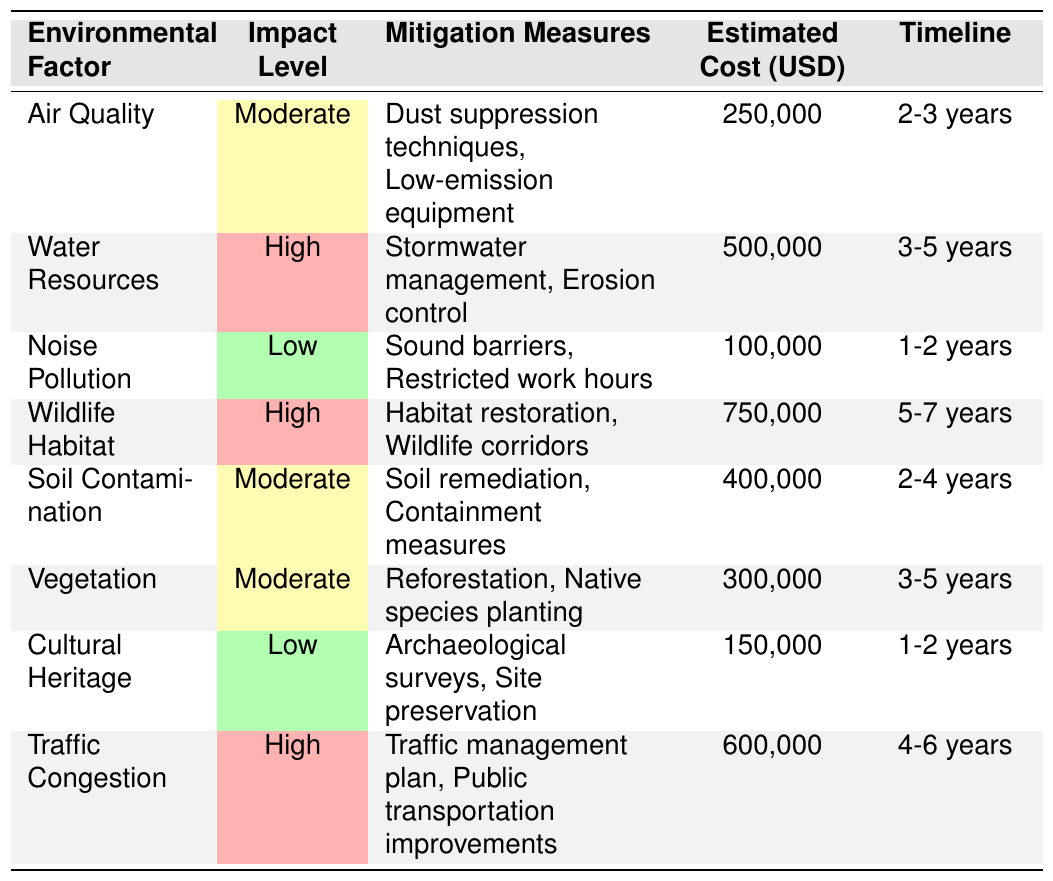What is the estimated cost for managing wildlife habitat? The table shows that the estimated cost for wildlife habitat management is listed as 750,000 USD.
Answer: 750,000 USD What mitigation measure is recommended for high water resource impact? For high water resource impact, the recommended mitigation measures are stormwater management and erosion control.
Answer: Stormwater management, erosion control Which environmental factor has the lowest impact level? Noise pollution and cultural heritage both have a low impact level indicated in the table.
Answer: Noise pollution and cultural heritage What is the total estimated cost for mitigating air quality and soil contamination? The estimated costs for air quality (250,000 USD) and soil contamination (400,000 USD) are summed: 250,000 + 400,000 = 650,000 USD.
Answer: 650,000 USD Are any environmental factors classified as having a moderate impact level? Yes, air quality, soil contamination, and vegetation are listed with a moderate impact level.
Answer: Yes How many years will it take to mitigate the water resources? The timeline for mitigating water resources is estimated at 3 to 5 years according to the table.
Answer: 3-5 years Which environmental factor requires the highest estimated cost for mitigation? The highest estimated cost for mitigation is for wildlife habitat, listed at 750,000 USD.
Answer: Wildlife habitat What is the average estimated cost of the environmental factors with high impact level? The high impact factors are water resources (500,000 USD), wildlife habitat (750,000 USD), and traffic congestion (600,000 USD). The total is 500,000 + 750,000 + 600,000 = 1,850,000 USD. With three factors, the average is 1,850,000 / 3 = 616,667 USD.
Answer: 616,667 USD Is there a mitigation measure for noise pollution? Yes, the table indicates sound barriers and restricted work hours as mitigation measures for noise pollution.
Answer: Yes What is the timeline for mitigating vegetation compared to traffic congestion? Vegetation has a timeline of 3-5 years, while traffic congestion has a timeline of 4-6 years. Thus, traffic congestion takes longer to mitigate than vegetation.
Answer: Traffic congestion takes longer 